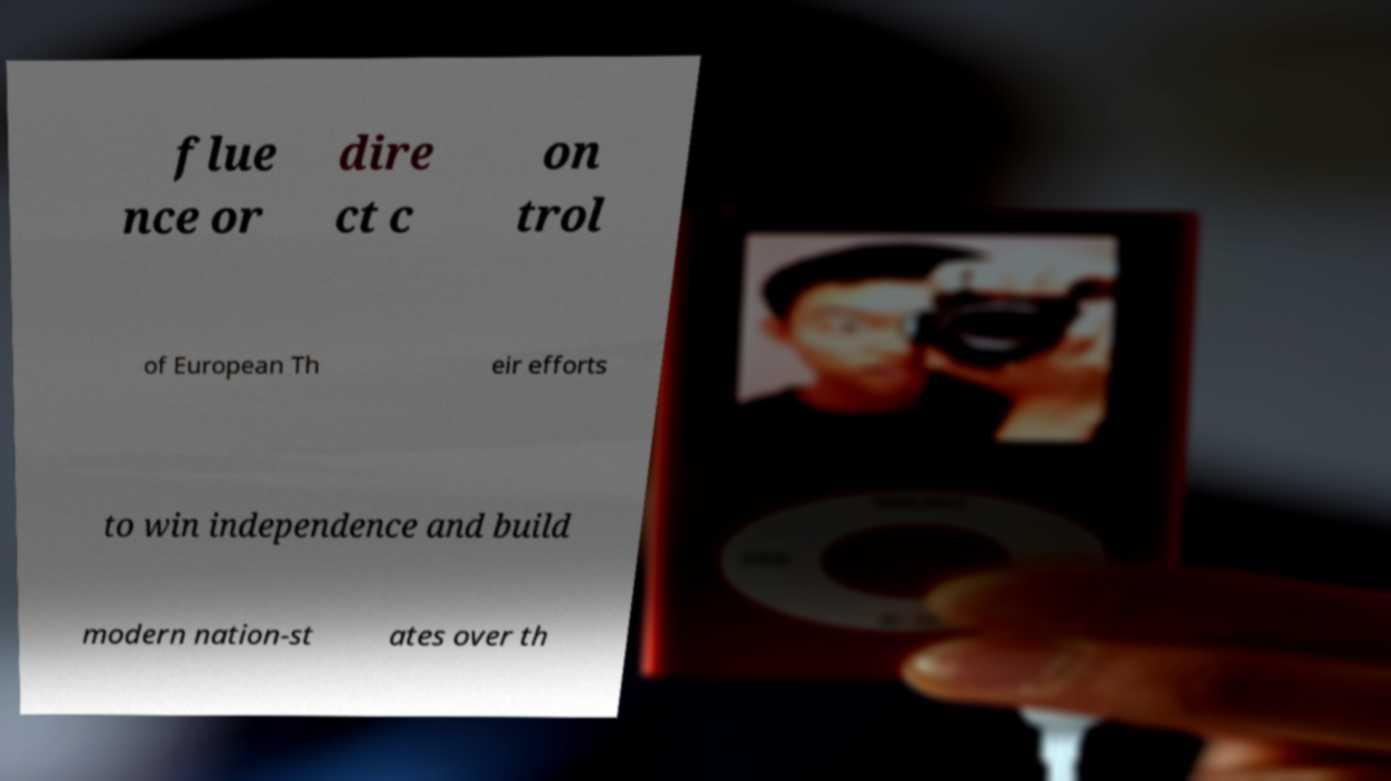There's text embedded in this image that I need extracted. Can you transcribe it verbatim? flue nce or dire ct c on trol of European Th eir efforts to win independence and build modern nation-st ates over th 